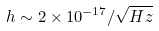Convert formula to latex. <formula><loc_0><loc_0><loc_500><loc_500>h \sim { 2 \times 1 0 ^ { - 1 7 } / { \sqrt { H z } } }</formula> 